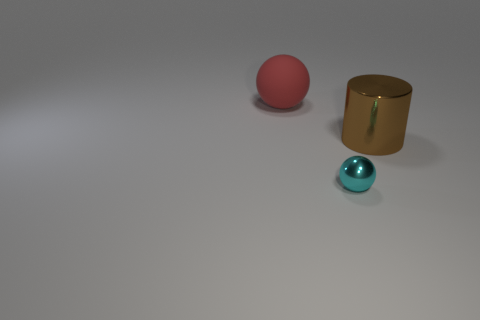Add 1 small cyan metallic balls. How many objects exist? 4 Subtract all cylinders. How many objects are left? 2 Add 1 big shiny cylinders. How many big shiny cylinders exist? 2 Subtract 1 cyan spheres. How many objects are left? 2 Subtract all big matte balls. Subtract all red objects. How many objects are left? 1 Add 1 tiny shiny balls. How many tiny shiny balls are left? 2 